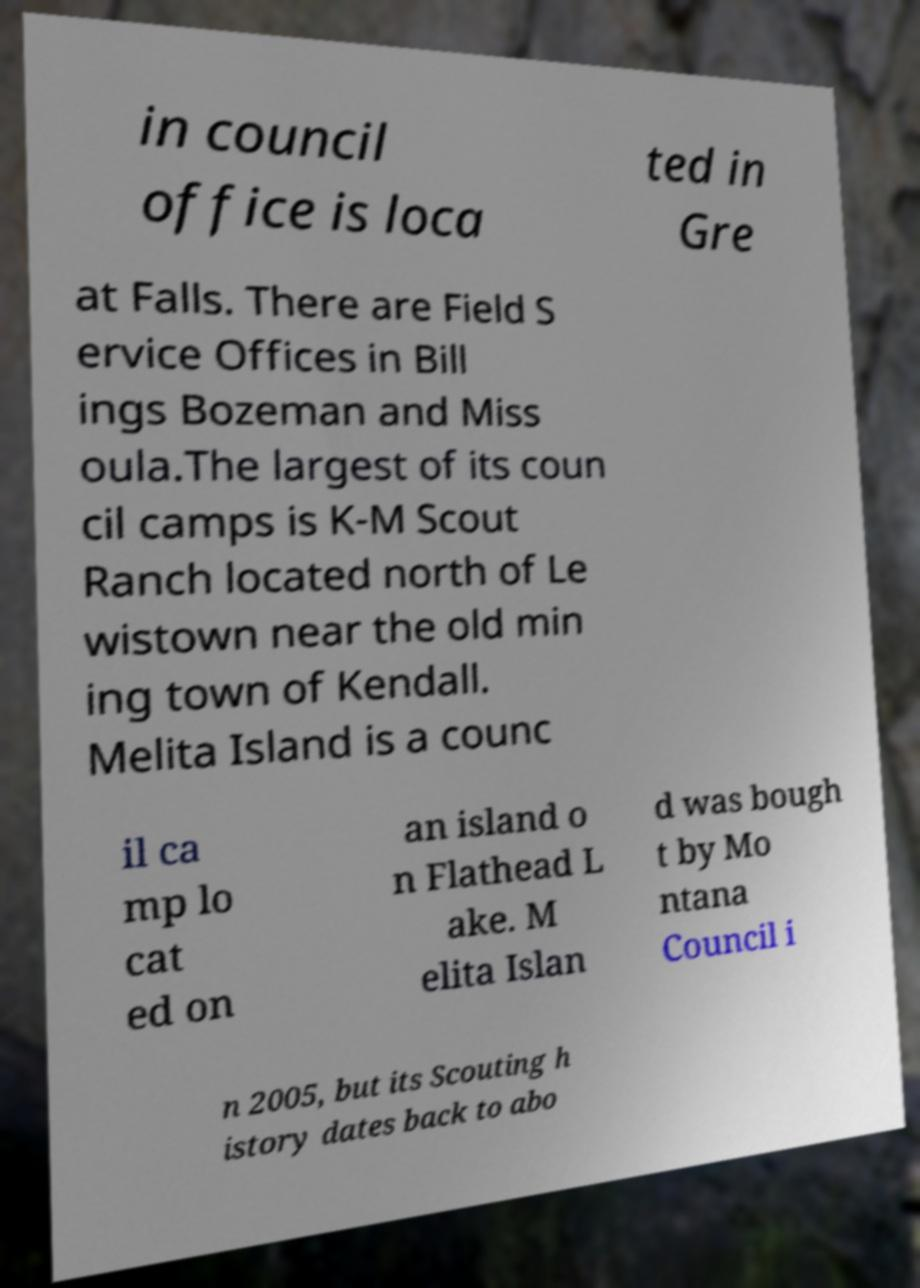For documentation purposes, I need the text within this image transcribed. Could you provide that? in council office is loca ted in Gre at Falls. There are Field S ervice Offices in Bill ings Bozeman and Miss oula.The largest of its coun cil camps is K-M Scout Ranch located north of Le wistown near the old min ing town of Kendall. Melita Island is a counc il ca mp lo cat ed on an island o n Flathead L ake. M elita Islan d was bough t by Mo ntana Council i n 2005, but its Scouting h istory dates back to abo 